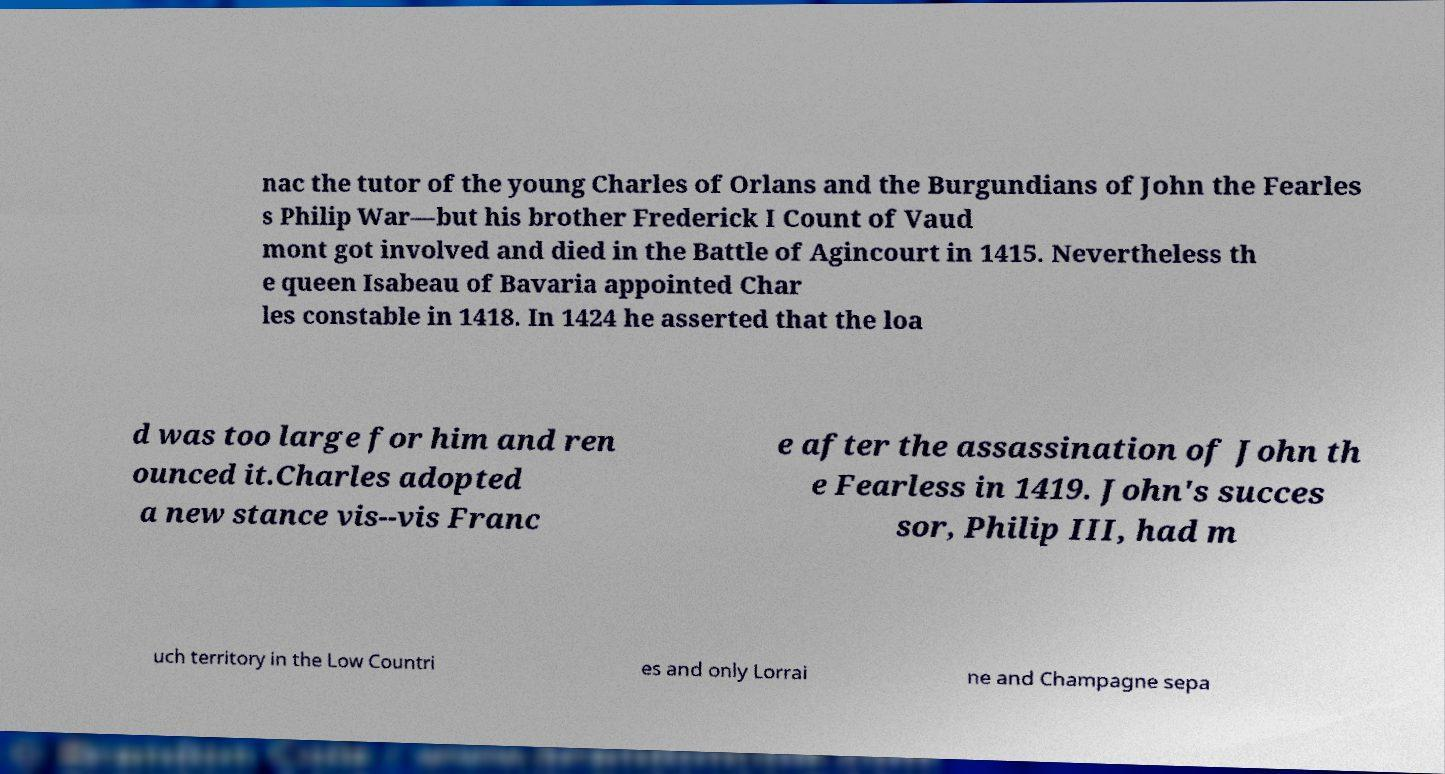Can you read and provide the text displayed in the image?This photo seems to have some interesting text. Can you extract and type it out for me? nac the tutor of the young Charles of Orlans and the Burgundians of John the Fearles s Philip War—but his brother Frederick I Count of Vaud mont got involved and died in the Battle of Agincourt in 1415. Nevertheless th e queen Isabeau of Bavaria appointed Char les constable in 1418. In 1424 he asserted that the loa d was too large for him and ren ounced it.Charles adopted a new stance vis--vis Franc e after the assassination of John th e Fearless in 1419. John's succes sor, Philip III, had m uch territory in the Low Countri es and only Lorrai ne and Champagne sepa 